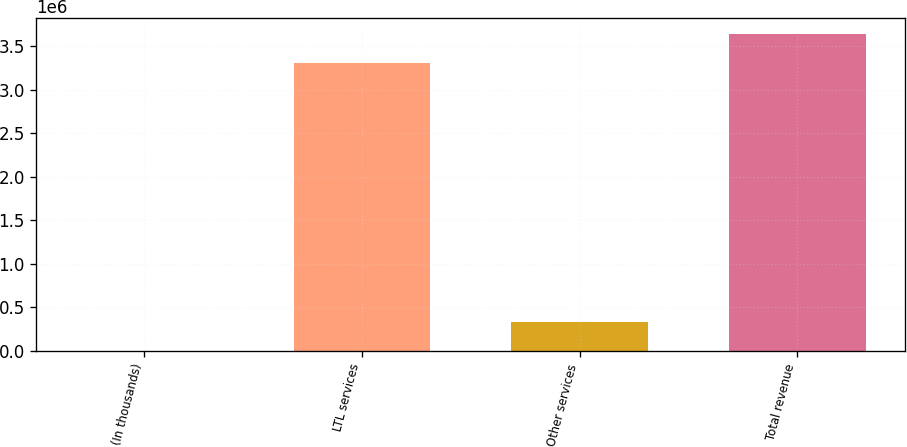Convert chart. <chart><loc_0><loc_0><loc_500><loc_500><bar_chart><fcel>(In thousands)<fcel>LTL services<fcel>Other services<fcel>Total revenue<nl><fcel>2017<fcel>3.30361e+06<fcel>337626<fcel>3.63922e+06<nl></chart> 